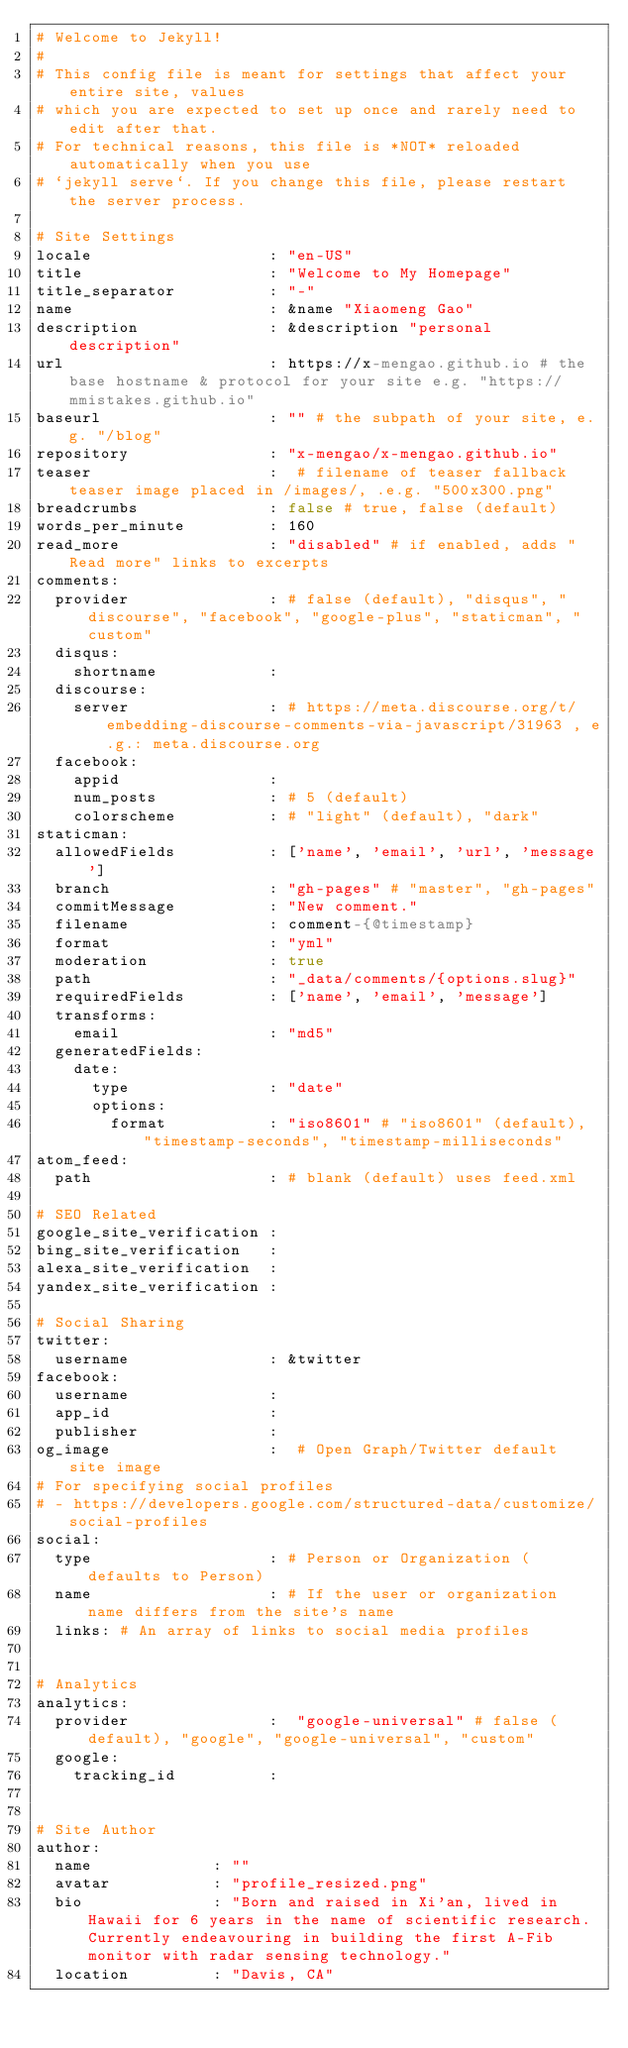<code> <loc_0><loc_0><loc_500><loc_500><_YAML_># Welcome to Jekyll!
#
# This config file is meant for settings that affect your entire site, values
# which you are expected to set up once and rarely need to edit after that.
# For technical reasons, this file is *NOT* reloaded automatically when you use
# `jekyll serve`. If you change this file, please restart the server process.

# Site Settings
locale                   : "en-US"
title                    : "Welcome to My Homepage"
title_separator          : "-"
name                     : &name "Xiaomeng Gao"
description              : &description "personal description"
url                      : https://x-mengao.github.io # the base hostname & protocol for your site e.g. "https://mmistakes.github.io"
baseurl                  : "" # the subpath of your site, e.g. "/blog"
repository               : "x-mengao/x-mengao.github.io"
teaser                   :  # filename of teaser fallback teaser image placed in /images/, .e.g. "500x300.png"
breadcrumbs              : false # true, false (default)
words_per_minute         : 160
read_more                : "disabled" # if enabled, adds "Read more" links to excerpts
comments:
  provider               : # false (default), "disqus", "discourse", "facebook", "google-plus", "staticman", "custom"
  disqus:
    shortname            :
  discourse:
    server               : # https://meta.discourse.org/t/embedding-discourse-comments-via-javascript/31963 , e.g.: meta.discourse.org
  facebook:
    appid                :
    num_posts            : # 5 (default)
    colorscheme          : # "light" (default), "dark"
staticman:
  allowedFields          : ['name', 'email', 'url', 'message']
  branch                 : "gh-pages" # "master", "gh-pages"
  commitMessage          : "New comment."
  filename               : comment-{@timestamp}
  format                 : "yml"
  moderation             : true
  path                   : "_data/comments/{options.slug}"
  requiredFields         : ['name', 'email', 'message']
  transforms:
    email                : "md5"
  generatedFields:
    date:
      type               : "date"
      options:
        format           : "iso8601" # "iso8601" (default), "timestamp-seconds", "timestamp-milliseconds"
atom_feed:
  path                   : # blank (default) uses feed.xml

# SEO Related
google_site_verification :
bing_site_verification   :
alexa_site_verification  :
yandex_site_verification :

# Social Sharing
twitter:
  username               : &twitter
facebook:
  username               :
  app_id                 :
  publisher              :
og_image                 :  # Open Graph/Twitter default site image
# For specifying social profiles
# - https://developers.google.com/structured-data/customize/social-profiles
social:
  type                   : # Person or Organization (defaults to Person)
  name                   : # If the user or organization name differs from the site's name
  links: # An array of links to social media profiles


# Analytics
analytics:
  provider               :  "google-universal" # false (default), "google", "google-universal", "custom"
  google:
    tracking_id          :


# Site Author
author:
  name             : ""
  avatar           : "profile_resized.png"
  bio              : "Born and raised in Xi'an, lived in Hawaii for 6 years in the name of scientific research. Currently endeavouring in building the first A-Fib monitor with radar sensing technology."
  location         : "Davis, CA"</code> 